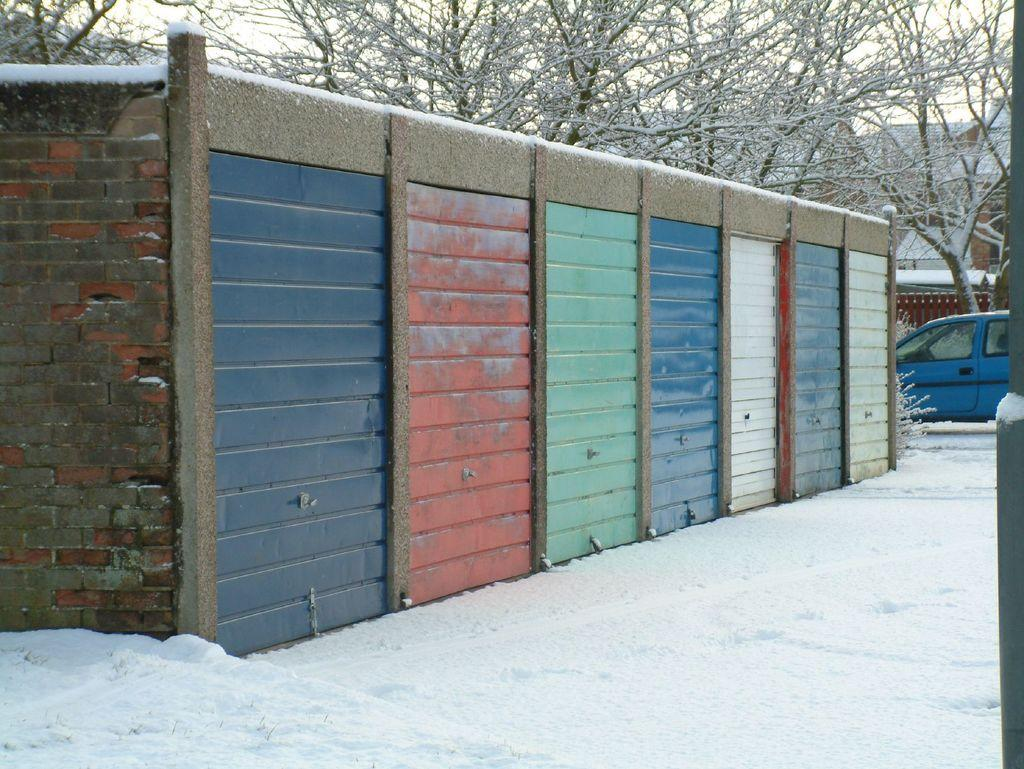What is the weather condition depicted in the image? There is snow in the image, indicating a cold or wintery weather condition. What type of vehicle can be seen in the image? There is a blue color car in the image. What type of natural elements are present in the image? There are trees in the image. What type of man-made structures are present in the image? There are buildings in the image. What type of barrier or divider is present in the image? There is a wall in the image. What colors can be seen on the wall in the image? The wall has blue, red, green, and white colors. What type of rock is being used for communication in the image? There is no rock present in the image, nor is there any communication taking place. What type of class is being held in the image? There is no class or educational setting depicted in the image. 